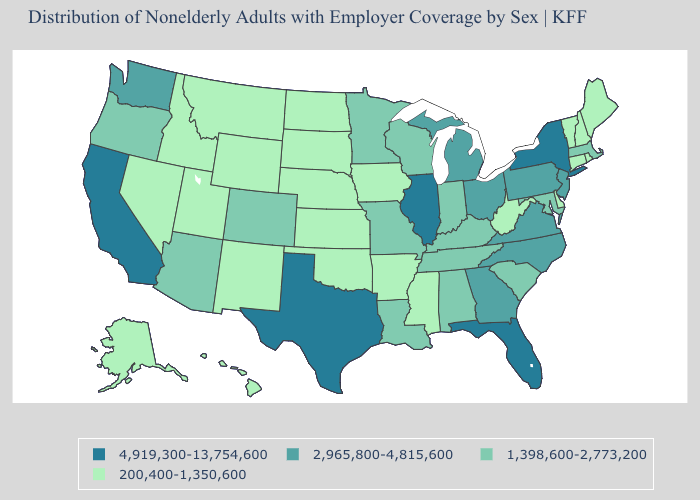Is the legend a continuous bar?
Write a very short answer. No. What is the lowest value in the South?
Quick response, please. 200,400-1,350,600. Among the states that border Maryland , which have the highest value?
Quick response, please. Pennsylvania, Virginia. Name the states that have a value in the range 200,400-1,350,600?
Give a very brief answer. Alaska, Arkansas, Connecticut, Delaware, Hawaii, Idaho, Iowa, Kansas, Maine, Mississippi, Montana, Nebraska, Nevada, New Hampshire, New Mexico, North Dakota, Oklahoma, Rhode Island, South Dakota, Utah, Vermont, West Virginia, Wyoming. Among the states that border Michigan , does Ohio have the lowest value?
Write a very short answer. No. Among the states that border Florida , does Georgia have the highest value?
Short answer required. Yes. Name the states that have a value in the range 200,400-1,350,600?
Answer briefly. Alaska, Arkansas, Connecticut, Delaware, Hawaii, Idaho, Iowa, Kansas, Maine, Mississippi, Montana, Nebraska, Nevada, New Hampshire, New Mexico, North Dakota, Oklahoma, Rhode Island, South Dakota, Utah, Vermont, West Virginia, Wyoming. Does Vermont have the lowest value in the Northeast?
Keep it brief. Yes. Name the states that have a value in the range 4,919,300-13,754,600?
Keep it brief. California, Florida, Illinois, New York, Texas. Is the legend a continuous bar?
Quick response, please. No. What is the lowest value in the South?
Concise answer only. 200,400-1,350,600. Does Vermont have the same value as Alaska?
Answer briefly. Yes. Does Florida have the highest value in the South?
Quick response, please. Yes. What is the value of South Carolina?
Short answer required. 1,398,600-2,773,200. Which states hav the highest value in the West?
Answer briefly. California. 